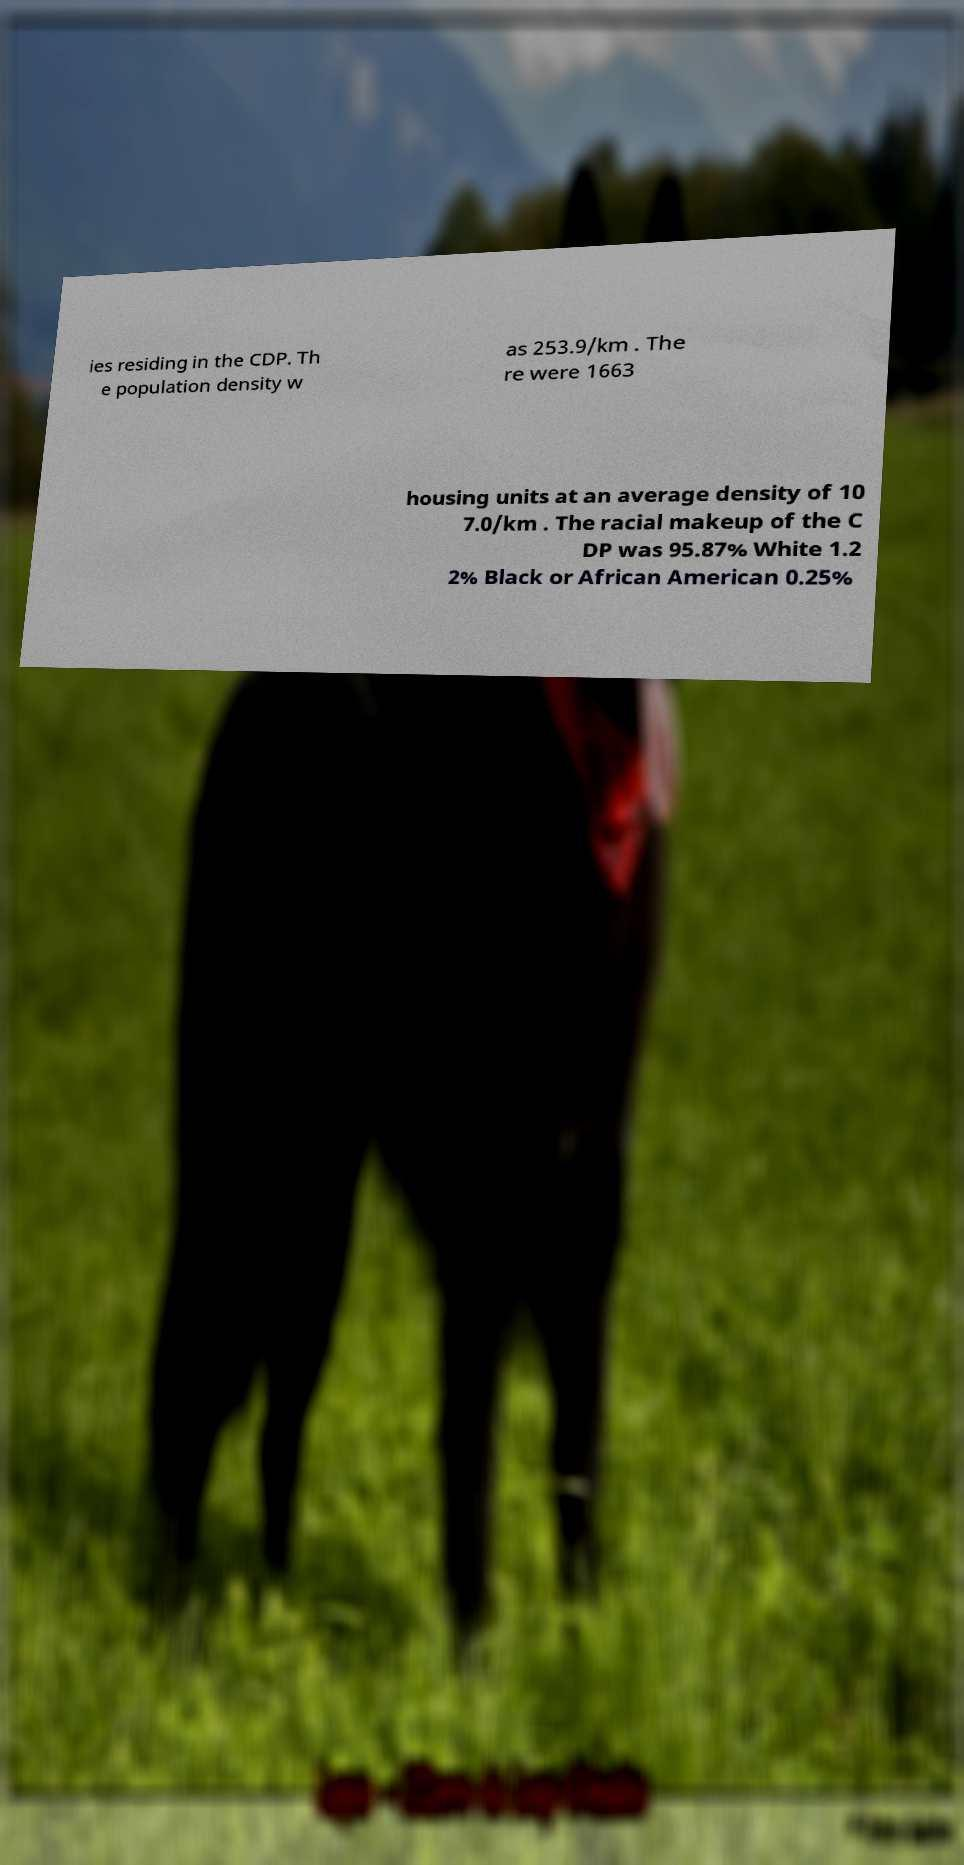Can you read and provide the text displayed in the image?This photo seems to have some interesting text. Can you extract and type it out for me? ies residing in the CDP. Th e population density w as 253.9/km . The re were 1663 housing units at an average density of 10 7.0/km . The racial makeup of the C DP was 95.87% White 1.2 2% Black or African American 0.25% 